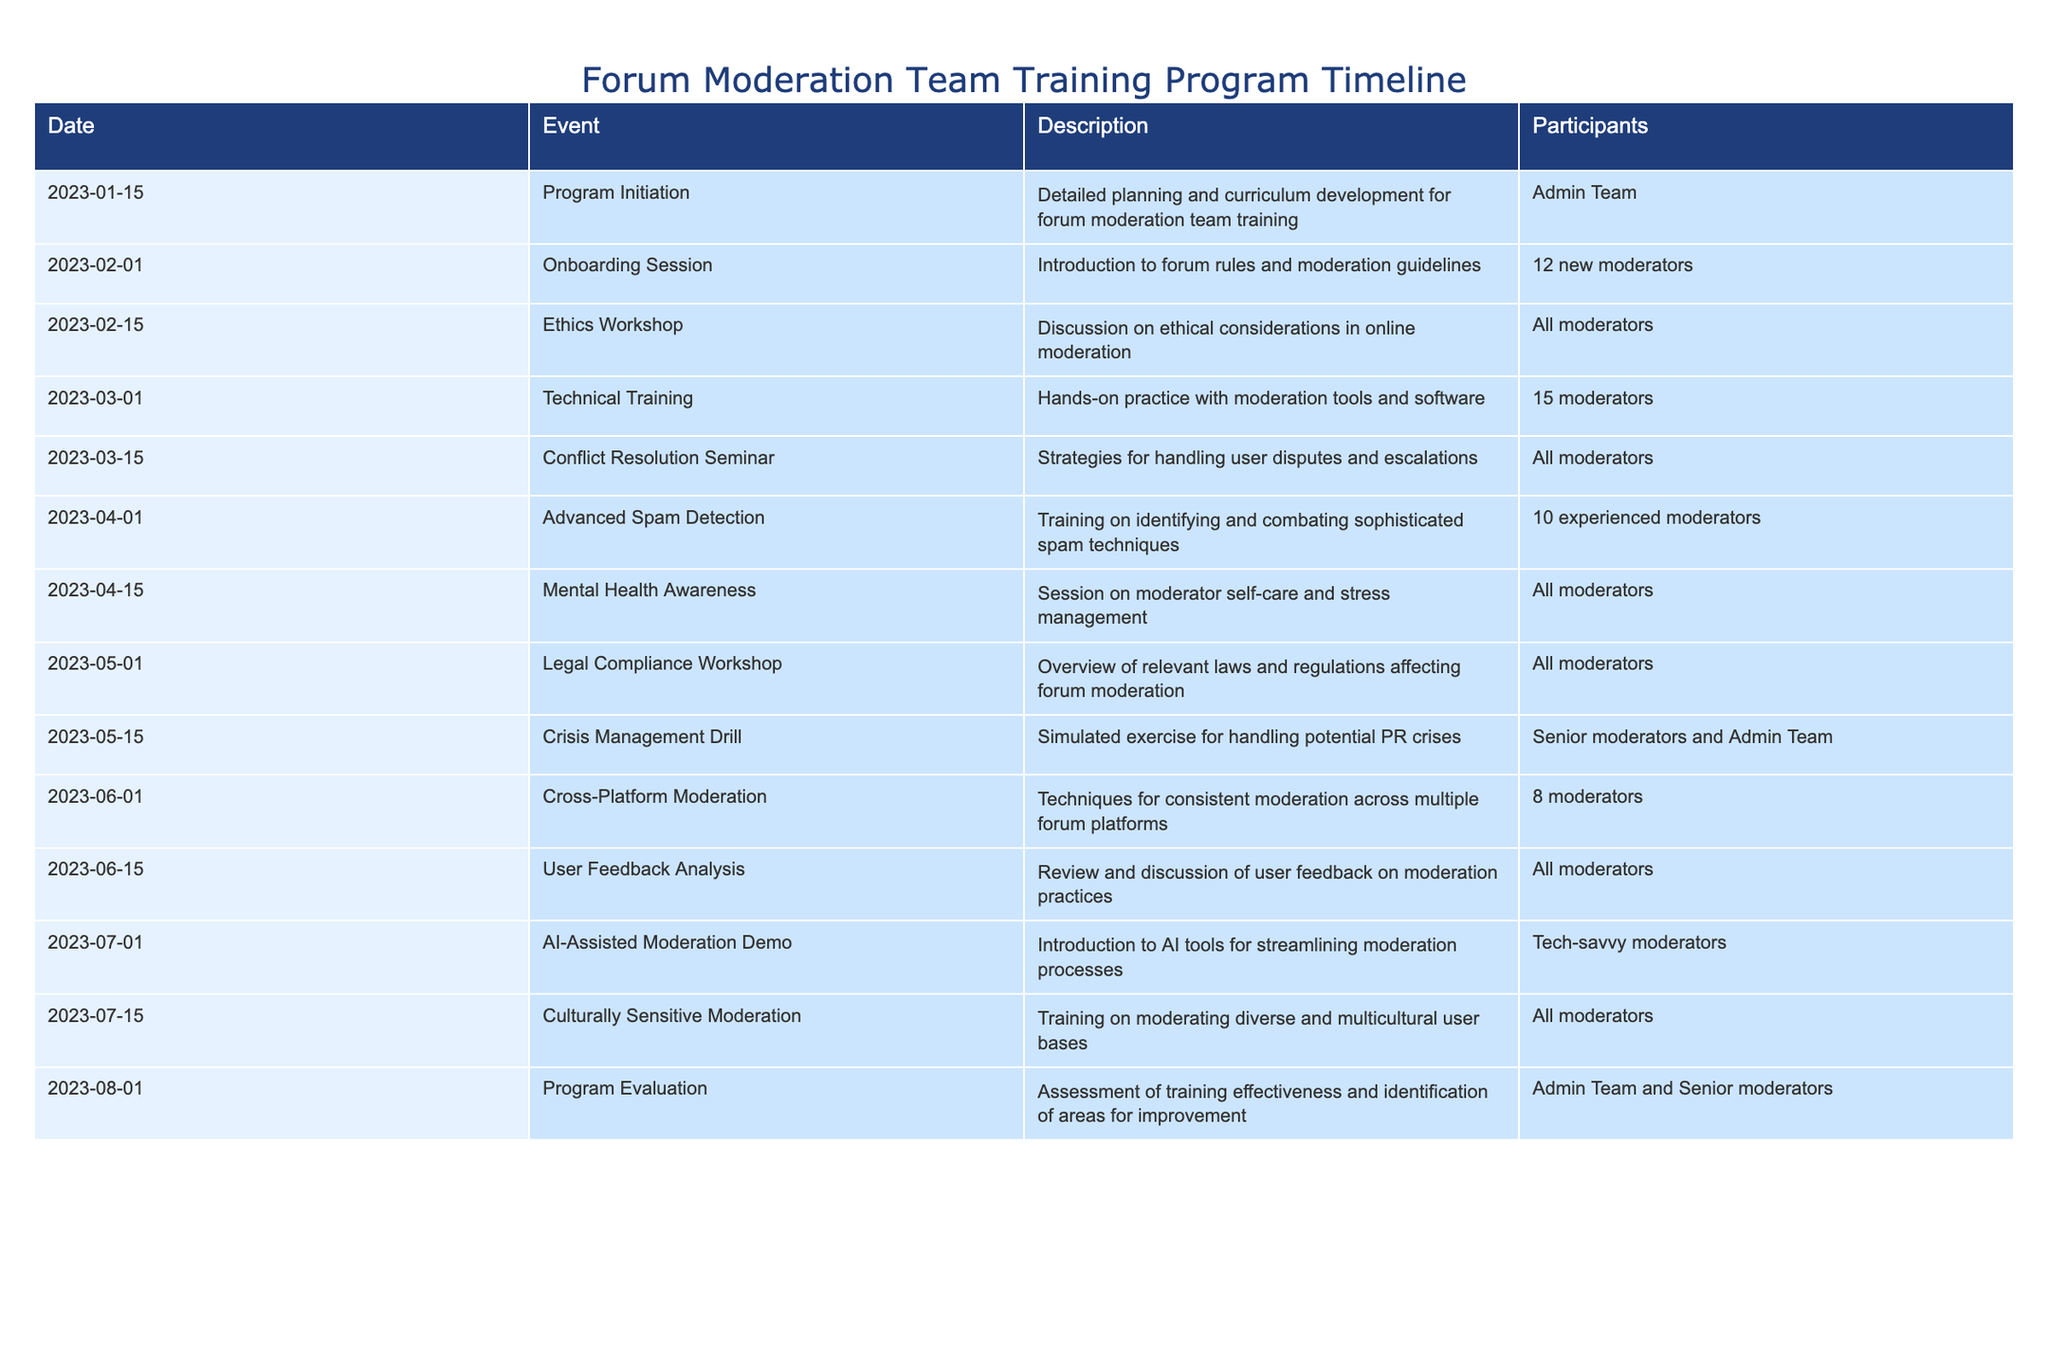What event took place on March 15, 2023? The table indicates that on March 15, 2023, a "Conflict Resolution Seminar" was held, which focused on strategies for handling user disputes and escalations, and included all moderators.
Answer: Conflict Resolution Seminar How many participants attended the Onboarding Session on February 1, 2023? According to the table, the Onboarding Session on February 1, 2023, had 12 new moderators participating.
Answer: 12 Which training sessions involved all moderators? The table lists several training sessions for all moderators: the Ethics Workshop, Conflict Resolution Seminar, Mental Health Awareness, Legal Compliance Workshop, User Feedback Analysis, and Culturally Sensitive Moderation.
Answer: Ethics Workshop, Conflict Resolution Seminar, Mental Health Awareness, Legal Compliance Workshop, User Feedback Analysis, Culturally Sensitive Moderation What is the average number of participants in the events listed in the table? To calculate the average, we first identify the number of participants for each event: 1 (Admin Team), 12 (new moderators), 15 (moderators), 10 (experienced moderators), 1 (All moderators), 1 (All moderators), 1 (All moderators), 2 (Senior moderators and Admin Team), 8 (moderators), and 1 (Tech-savvy moderators). Adding these up gives 50 participants. There are 10 events, so the average is 50/10 = 5.
Answer: 5 Was there any training regarding the use of AI tools? Yes, the table shows that on July 1, 2023, there was an "AI-Assisted Moderation Demo" which introduced AI tools for streamlining moderation processes.
Answer: Yes What was the most recent event in the training program? The table indicates that the most recent event took place on August 1, 2023, which was the Program Evaluation, aimed at assessing training effectiveness and identifying areas for improvement.
Answer: Program Evaluation 